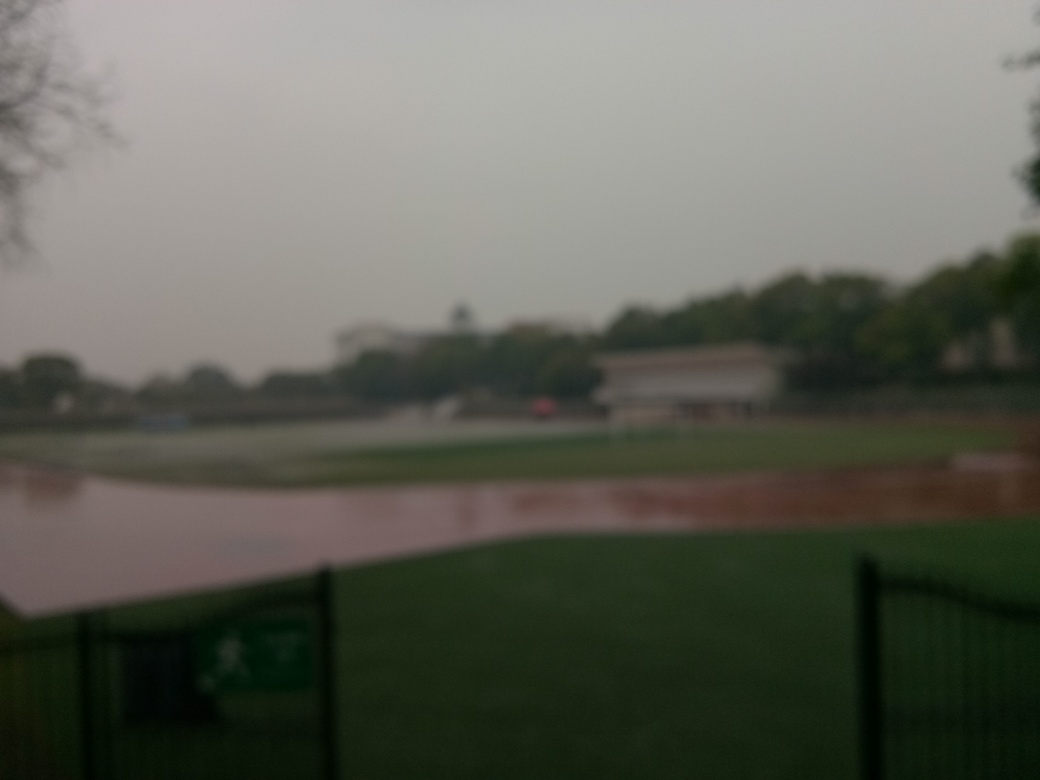What activities do you think are commonly enjoyed at this place? Given the appearance of an expansive grassy area, this place likely serves as a ground for various recreational activities. On a clearer day, you might see people engaging in sports like soccer or cricket, enjoying picnics, jogging, walking dogs, or simply relaxing in the open space.  Could the weather be affecting the quality of the image? Definitely. The blurred quality and the low contrast suggest that the weather might be foggy or misty, perhaps indicative of early morning or rainy conditions. These weather factors can significantly diminish the clarity of photographs and make details harder to discern. 